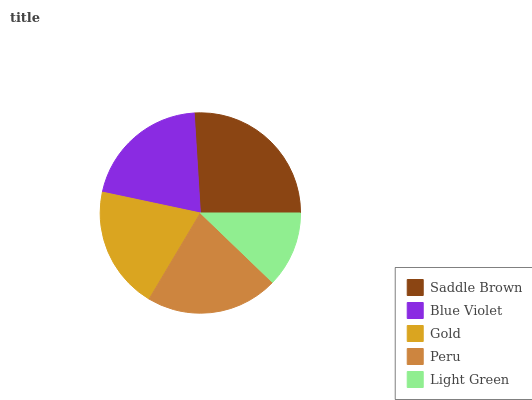Is Light Green the minimum?
Answer yes or no. Yes. Is Saddle Brown the maximum?
Answer yes or no. Yes. Is Blue Violet the minimum?
Answer yes or no. No. Is Blue Violet the maximum?
Answer yes or no. No. Is Saddle Brown greater than Blue Violet?
Answer yes or no. Yes. Is Blue Violet less than Saddle Brown?
Answer yes or no. Yes. Is Blue Violet greater than Saddle Brown?
Answer yes or no. No. Is Saddle Brown less than Blue Violet?
Answer yes or no. No. Is Blue Violet the high median?
Answer yes or no. Yes. Is Blue Violet the low median?
Answer yes or no. Yes. Is Light Green the high median?
Answer yes or no. No. Is Peru the low median?
Answer yes or no. No. 